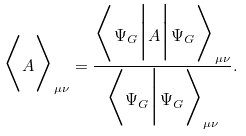Convert formula to latex. <formula><loc_0><loc_0><loc_500><loc_500>\Big \langle { A } \Big \rangle _ { \mu \nu } = \frac { \Big \langle { \Psi _ { G } } \Big | A \Big | { \Psi _ { G } } \Big \rangle _ { \mu \nu } } { \Big \langle { \Psi _ { G } } \Big | { \Psi _ { G } } \Big \rangle _ { \mu \nu } } .</formula> 